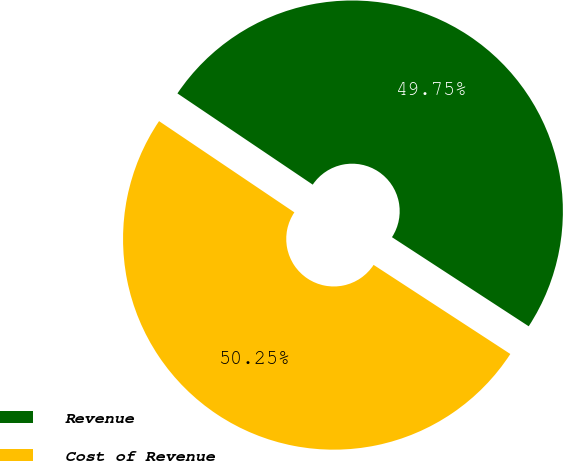Convert chart to OTSL. <chart><loc_0><loc_0><loc_500><loc_500><pie_chart><fcel>Revenue<fcel>Cost of Revenue<nl><fcel>49.75%<fcel>50.25%<nl></chart> 